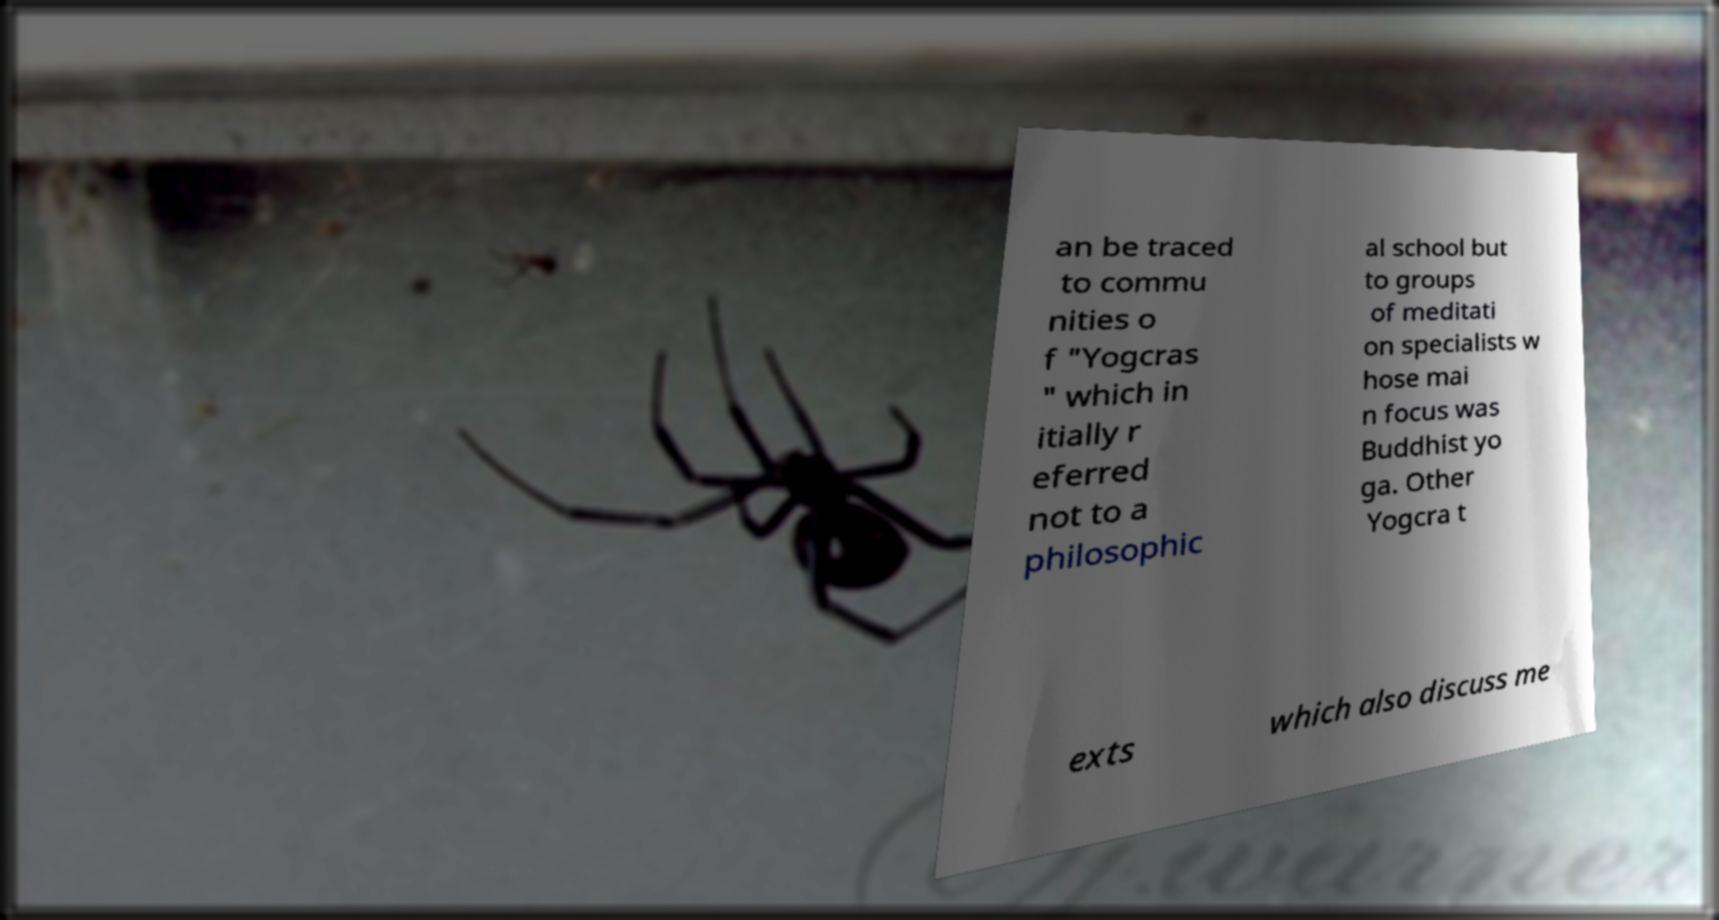Could you assist in decoding the text presented in this image and type it out clearly? an be traced to commu nities o f "Yogcras " which in itially r eferred not to a philosophic al school but to groups of meditati on specialists w hose mai n focus was Buddhist yo ga. Other Yogcra t exts which also discuss me 